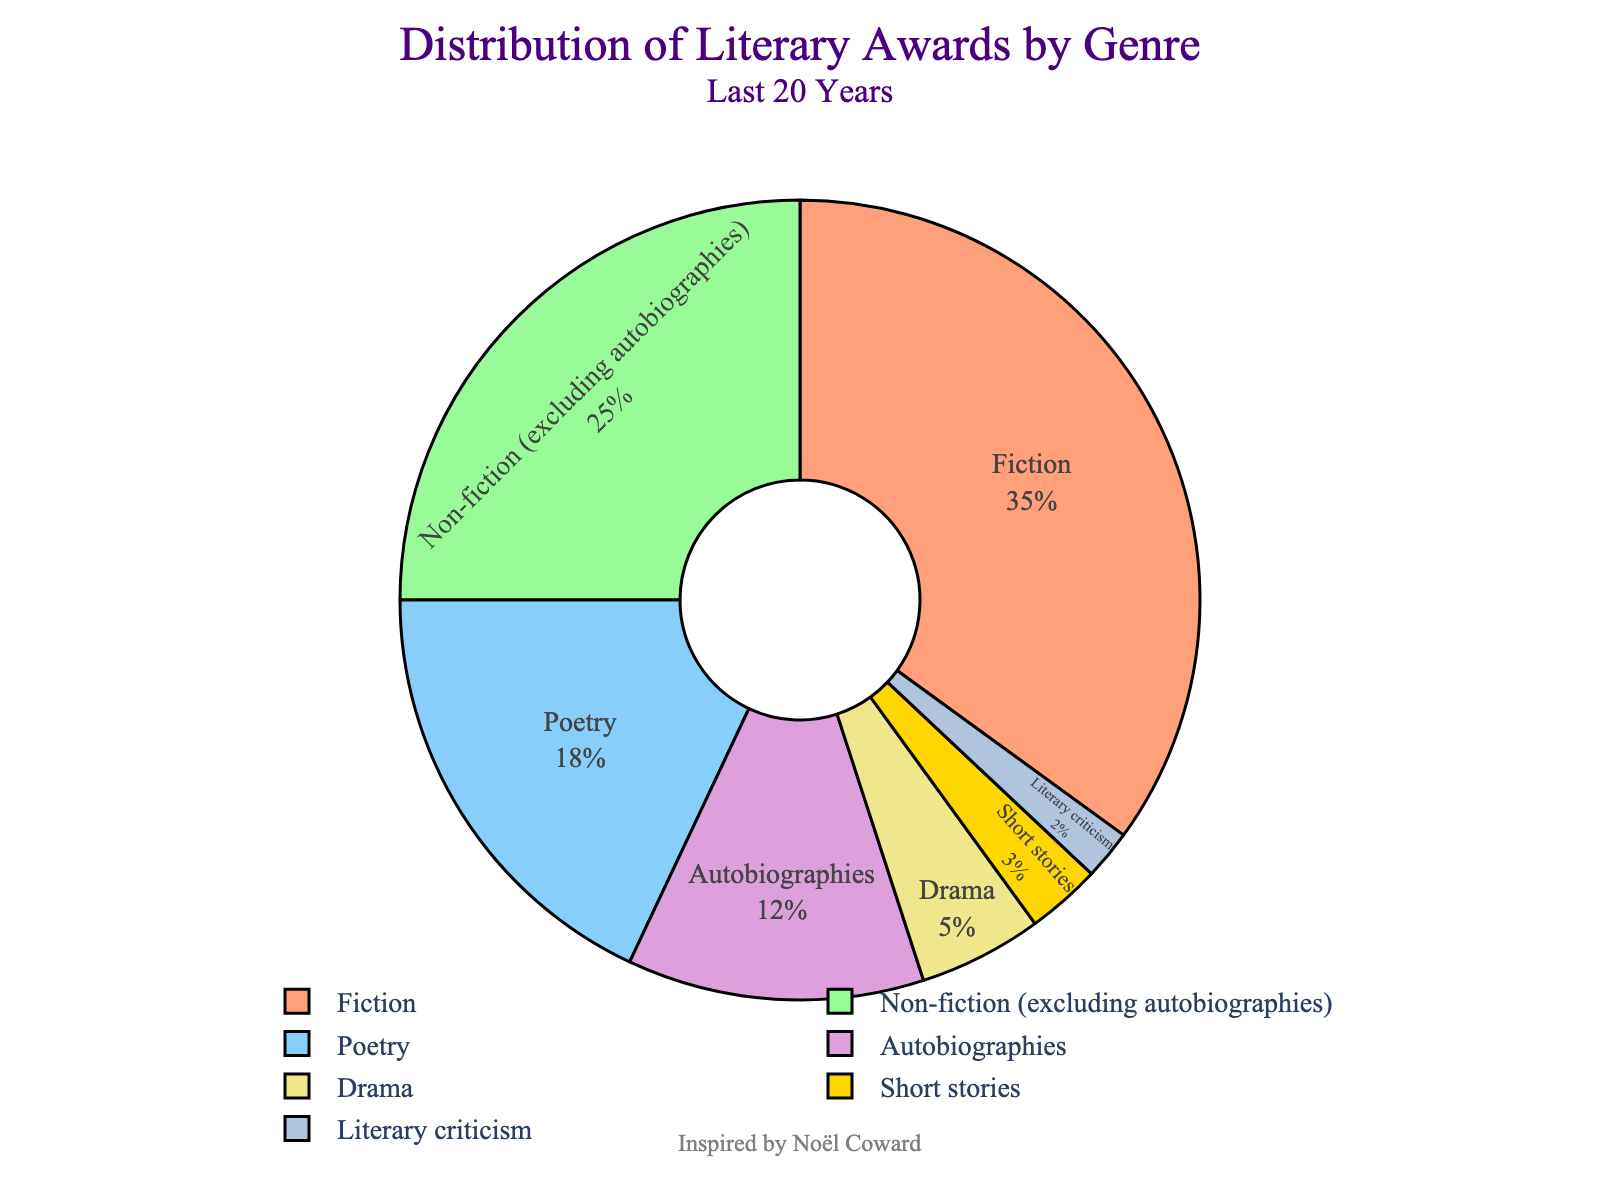what genre received the highest proportion of literary awards in the last 20 years? We start by identifying which genre occupies the largest segment of the pie chart. From the figure, “Fiction” is visually the largest slice.
Answer: Fiction How much larger is the proportion of awards for Fiction compared to Autobiographies? First, locate the percentages for Fiction (35%) and Autobiographies (12%) in the figure. Next, subtract the percentage for Autobiographies from that for Fiction: 35 - 12 = 23.
Answer: 23% What is the combined percentage of literary awards for Fiction and Poetry? Add the percentages for Fiction (35%) and Poetry (18%) seen in the chart: 35 + 18 = 53.
Answer: 53% Which genres received fewer literary awards than Autobiographies? Observe the Autobiographies segment (12%) and identify all segments smaller than it. These smaller segments include Drama (5%), Short stories (3%), and Literary criticism (2%).
Answer: Drama, Short stories, Literary criticism What's the total percentage of awards given to Non-fiction (excluding Autobiographies) and Poetry? Sum the percentages from the chart: Non-fiction (excluding autobiographies) is 25% and Poetry is 18%. So we calculate 25 + 18 = 43.
Answer: 43% Visually, which genre has the smallest share of literary awards, and what is its percentage? Identify the smallest segment in the pie chart, which is visually the smallest. Literary criticism has the smallest share with 2% as indicated in the figure.
Answer: Literary criticism, 2% Is the combined proportion of awards for Drama and Short stories greater than that for Autobiographies? Sum the percentages for Drama (5%) and Short stories (3%): 5 + 3 = 8. Compare this with the percentage for Autobiographies (12%). Since 8 is less than 12, the combined proportion for Drama and Short stories is not greater than that for Autobiographies.
Answer: No What's the average percentage of awards for Non-fiction (excluding autobiographies) and Drama? Locate the percentages for Non-fiction (excluding autobiographies) (25%) and Drama (5%). Add these values: 25 + 5 = 30, then divide by 2 to find the average: 30 / 2 = 15.
Answer: 15% Which genres together make up approximately half of the total literary awards' percentage? Examine the percentages to find a combination that sums up to around 50%. Fiction (35%) and Poetry (18%) together sum to 53%, close to half of the total.
Answer: Fiction and Poetry Compare the proportion of awards for Autobiographies and Short stories. Is the percentage for Autobiographies more than twice that for Short stories? Autobiographies have 12% and Short stories have 3%. Calculate twice the percentage of Short stories: 2 * 3 = 6. Compare this with the 12% for Autobiographies. Since 12 is more than 6, the percentage for Autobiographies is indeed more than twice that for Short stories.
Answer: Yes 